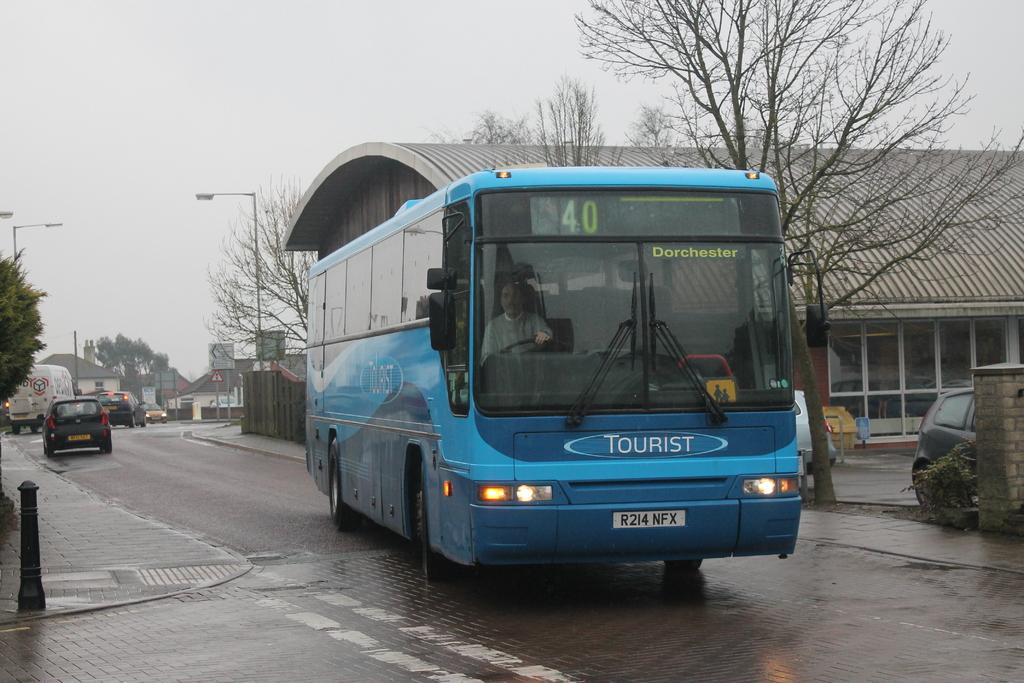<image>
Share a concise interpretation of the image provided. a number 40 bus that says tourist on the front of it 